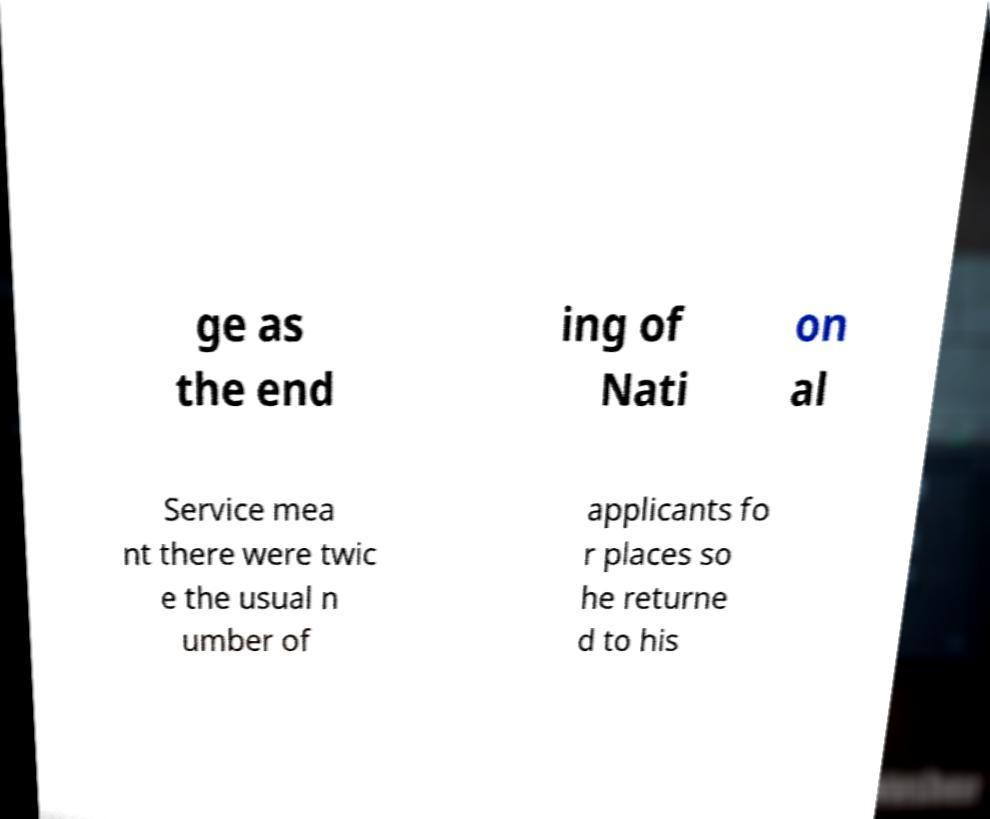For documentation purposes, I need the text within this image transcribed. Could you provide that? ge as the end ing of Nati on al Service mea nt there were twic e the usual n umber of applicants fo r places so he returne d to his 